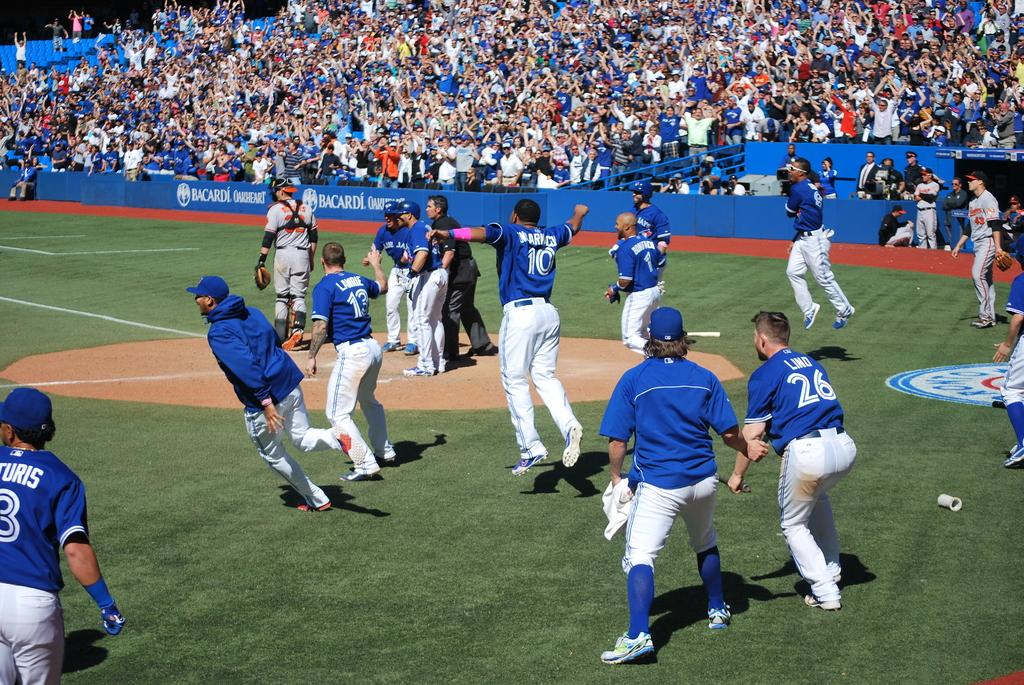<image>
Describe the image concisely. The walls of the baseball stadium are unusually uncrowded, with Bacardi being the only company advertised. 